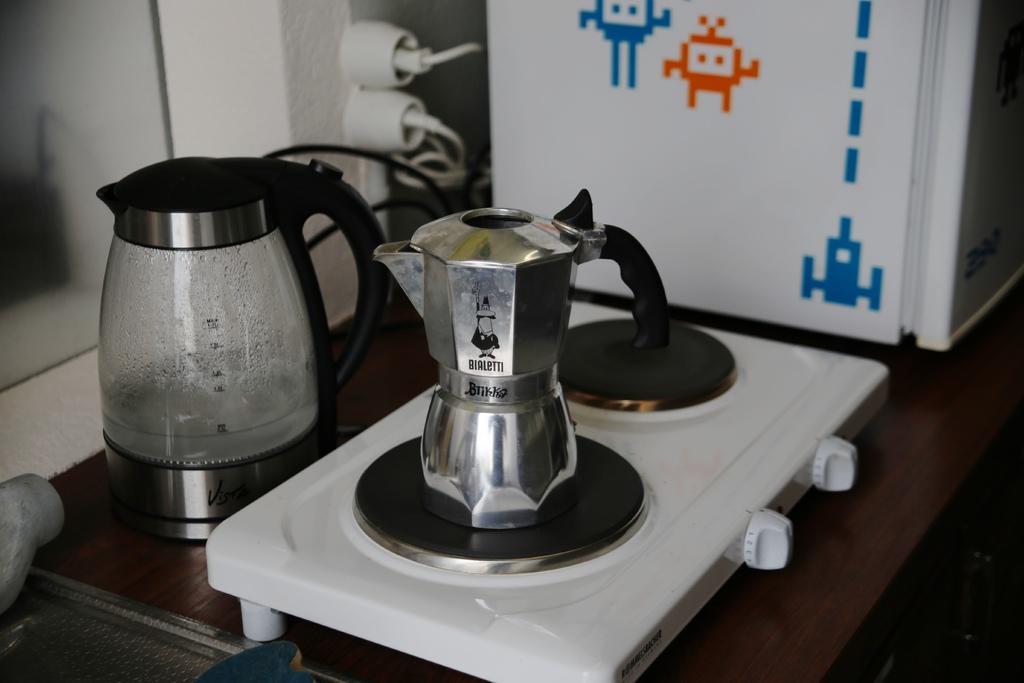What is the brand of kitchen appliance shown?
Your answer should be compact. Bialetti. 